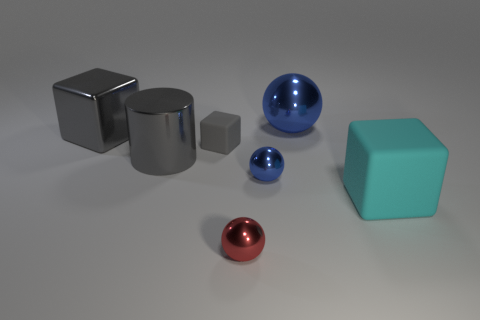What shape is the shiny object that is the same color as the big metallic ball?
Your response must be concise. Sphere. There is a metallic cube that is the same color as the small matte object; what is its size?
Offer a very short reply. Large. There is a large metallic block; is its color the same as the small sphere that is in front of the cyan matte cube?
Keep it short and to the point. No. There is a tiny rubber object; are there any metallic cylinders right of it?
Provide a succinct answer. No. There is a matte cube to the right of the big shiny ball; is it the same size as the blue metal object in front of the gray shiny block?
Offer a terse response. No. Is there a gray metallic block of the same size as the cylinder?
Make the answer very short. Yes. Do the blue shiny object that is to the left of the big blue sphere and the tiny gray matte thing have the same shape?
Offer a terse response. No. There is a large cube that is left of the big blue shiny thing; what is its material?
Your response must be concise. Metal. What shape is the large gray object that is in front of the gray rubber block in front of the large blue thing?
Ensure brevity in your answer.  Cylinder. There is a small rubber object; does it have the same shape as the blue object behind the tiny rubber object?
Make the answer very short. No. 